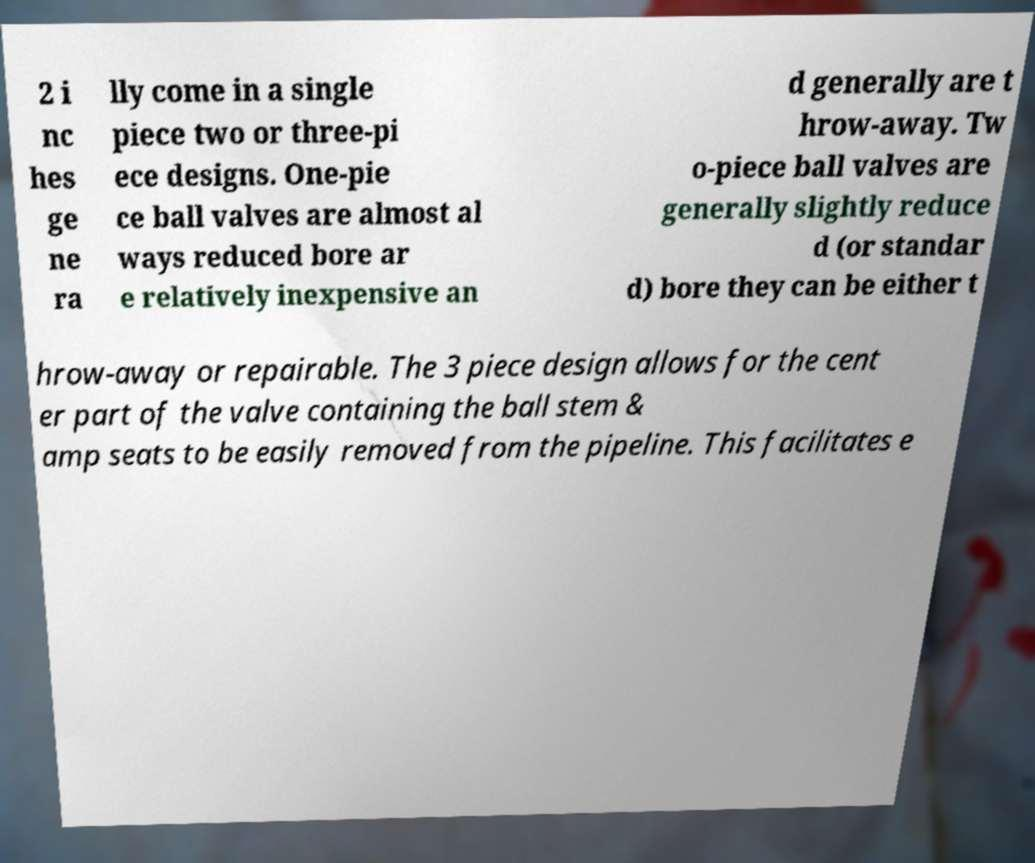Can you accurately transcribe the text from the provided image for me? 2 i nc hes ge ne ra lly come in a single piece two or three-pi ece designs. One-pie ce ball valves are almost al ways reduced bore ar e relatively inexpensive an d generally are t hrow-away. Tw o-piece ball valves are generally slightly reduce d (or standar d) bore they can be either t hrow-away or repairable. The 3 piece design allows for the cent er part of the valve containing the ball stem & amp seats to be easily removed from the pipeline. This facilitates e 